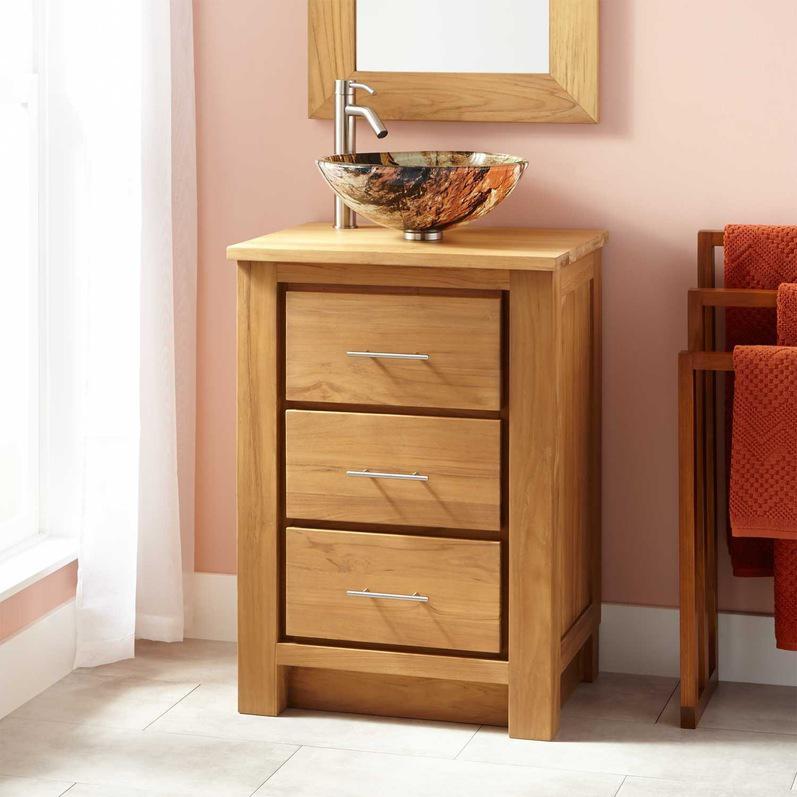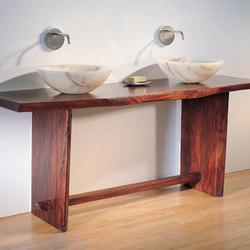The first image is the image on the left, the second image is the image on the right. Evaluate the accuracy of this statement regarding the images: "One of the images shows a basin with no faucet.". Is it true? Answer yes or no. No. The first image is the image on the left, the second image is the image on the right. Examine the images to the left and right. Is the description "Photo contains single white sink." accurate? Answer yes or no. No. 